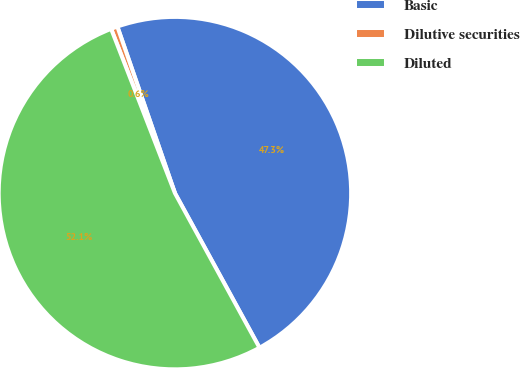<chart> <loc_0><loc_0><loc_500><loc_500><pie_chart><fcel>Basic<fcel>Dilutive securities<fcel>Diluted<nl><fcel>47.33%<fcel>0.6%<fcel>52.07%<nl></chart> 